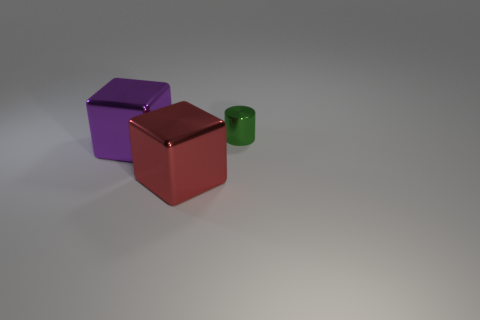There is a large red block; what number of big metal objects are to the left of it?
Offer a very short reply. 1. What is the color of the other thing that is the same shape as the purple shiny thing?
Your answer should be compact. Red. There is a object that is in front of the purple object; is it the same size as the large purple metallic object?
Offer a very short reply. Yes. There is a large metallic thing that is on the left side of the large red block; what color is it?
Your response must be concise. Purple. What number of small things are either green cylinders or purple objects?
Provide a short and direct response. 1. Is the color of the shiny block that is behind the large red shiny cube the same as the large metal block that is to the right of the large purple cube?
Give a very brief answer. No. What number of other things are the same color as the metal cylinder?
Offer a terse response. 0. How many yellow objects are small things or large cubes?
Your answer should be compact. 0. There is a green metal thing; does it have the same shape as the thing to the left of the red thing?
Keep it short and to the point. No. The big red object is what shape?
Offer a very short reply. Cube. 